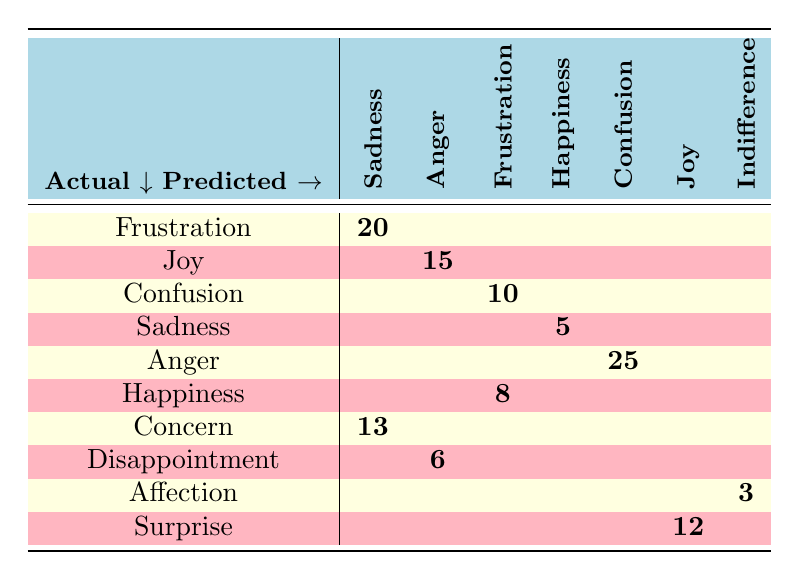What is the count of misunderstandings where frustration was predicted to be sadness? The table indicates that there are 20 instances where the actual emotion of frustration was misinterpreted as sadness.
Answer: 20 How many times did joy get misinterpreted as anger? Referring to the table, joy was predicted to be anger in 15 instances.
Answer: 15 Which actual emotion was most commonly predicted as confusion? The table shows that anger was predicted to be confusion 25 times, which is the highest count relative to other emotions.
Answer: Anger What is the total count of misunderstandings for the actual emotion "concern"? By looking at the table, concern had a total of 13 instances misclassified as sadness, leading to a total of 13 misunderstandings.
Answer: 13 Is it true that happiness was predicted as frustration more than sadness was predicted as happiness? Checking the counts, happiness being predicted as frustration appeared 8 times, while sadness predicted as happiness occurred 5 times, confirming the statement is true.
Answer: Yes What is the sum of all misunderstandings where actual emotions were predicted as sadness? The actual emotions predicted as sadness in the table are frustration (20) and concern (13). Summing these gives 20 + 13 = 33 instances in total.
Answer: 33 How many actual emotions were misinterpreted as indifference? The data shows that affection was the only emotion misinterpreted as indifference, with a count of 3. Thus, there is only one such misinterpretation.
Answer: 1 Which predicted emotion had the highest count of misunderstandings overall? Analyzing the counts in the table, confusion had the highest count of misunderstandings predicted from anger (25), while sadness had 20 (from frustration) and joy had 12 (from surprise). Hence, confusion stands out as having the most.
Answer: Confusion What is the average number of misunderstandings for the actual emotions joy and happiness? The misunderstandings for joy are 15 (predicted as anger) and for happiness 8 (predicted as frustration). Summing these gives 15 + 8 = 23 total instances, and dividing by the 2 emotions gives an average of 11.5.
Answer: 11.5 